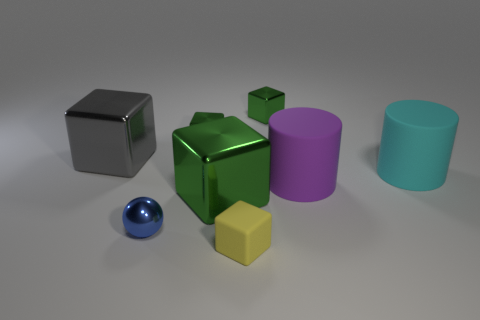Is there any other thing that has the same shape as the blue object?
Provide a short and direct response. No. There is a big thing that is both behind the large purple cylinder and on the right side of the small yellow block; what is its material?
Keep it short and to the point. Rubber. Do the matte object that is on the left side of the purple cylinder and the big metal thing behind the big green block have the same shape?
Provide a succinct answer. Yes. How many objects are either tiny yellow things in front of the large green object or large green matte blocks?
Your answer should be compact. 1. Do the gray metal cube and the sphere have the same size?
Provide a succinct answer. No. There is a small metallic cube that is to the left of the yellow matte object; what is its color?
Make the answer very short. Green. What size is the purple cylinder that is the same material as the big cyan cylinder?
Offer a terse response. Large. Does the gray shiny cube have the same size as the green metallic block in front of the big cyan thing?
Give a very brief answer. Yes. There is a big cube that is in front of the gray block; what is its material?
Offer a very short reply. Metal. There is a tiny green object right of the yellow rubber object; how many green blocks are on the left side of it?
Your answer should be compact. 2. 